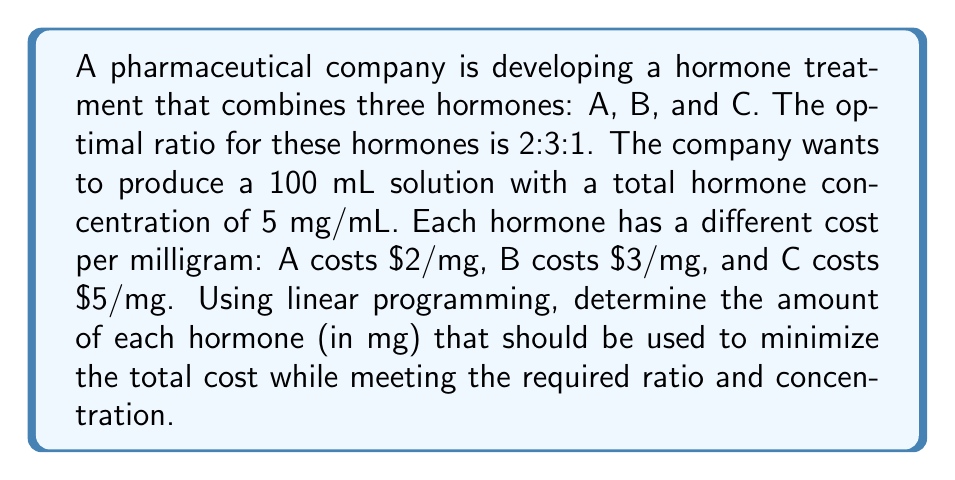What is the answer to this math problem? Let's approach this step-by-step using linear programming:

1) Define variables:
   Let $x$, $y$, and $z$ be the amounts (in mg) of hormones A, B, and C respectively.

2) Objective function:
   Minimize total cost: $2x + 3y + 5z$

3) Constraints:
   a) Ratio constraint: $x : y : z = 2 : 3 : 1$
      This can be written as: $3x = 2y$ and $x = 2z$
   b) Total concentration: $x + y + z = 500$ (5 mg/mL * 100 mL)

4) From the ratio constraint:
   $x = 2z$ and $y = 3z$

5) Substitute these into the total concentration constraint:
   $2z + 3z + z = 500$
   $6z = 500$
   $z = 500/6 = 83.33$ mg

6) Now we can find $x$ and $y$:
   $x = 2z = 2(83.33) = 166.67$ mg
   $y = 3z = 3(83.33) = 250$ mg

7) Verify the total:
   $166.67 + 250 + 83.33 = 500$ mg (which is correct)

8) Calculate the total cost:
   Cost = $2(166.67) + 3(250) + 5(83.33) = 1583.33$

Therefore, the optimal amounts are:
Hormone A: 166.67 mg
Hormone B: 250 mg
Hormone C: 83.33 mg

This solution minimizes the cost while meeting the required ratio and concentration.
Answer: A: 166.67 mg, B: 250 mg, C: 83.33 mg 